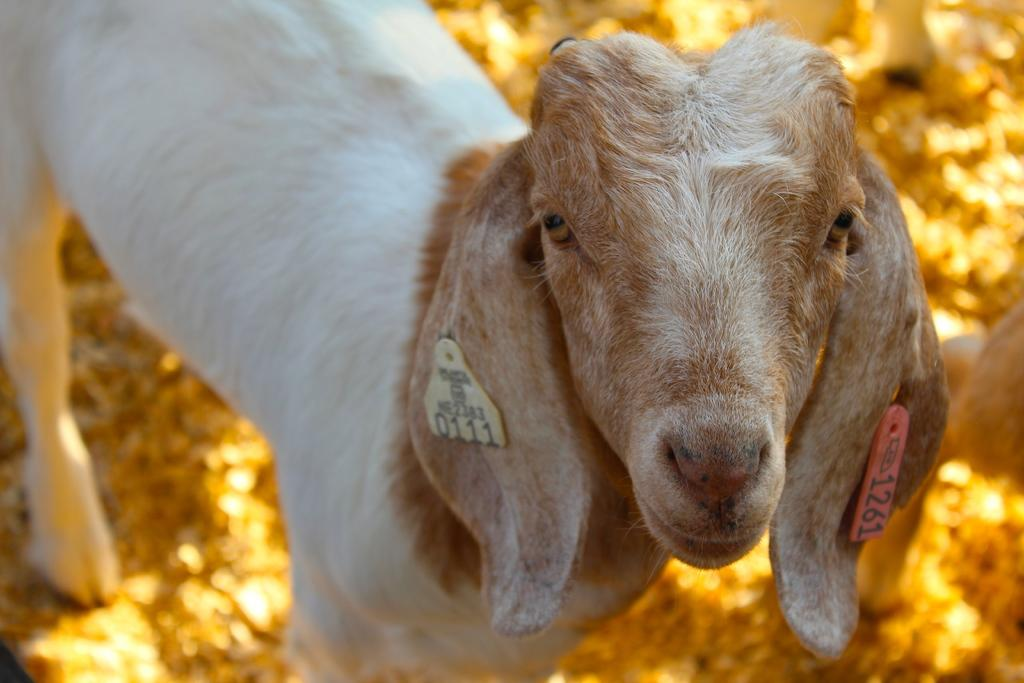What animal is the main subject of the image? There is a goat in the image. Can you describe any unique features of the goat? The goat has tags on its ears. What type of offer is the duck making to the bird in the image? There is no duck or bird present in the image; it only features a goat with tags on its ears. 